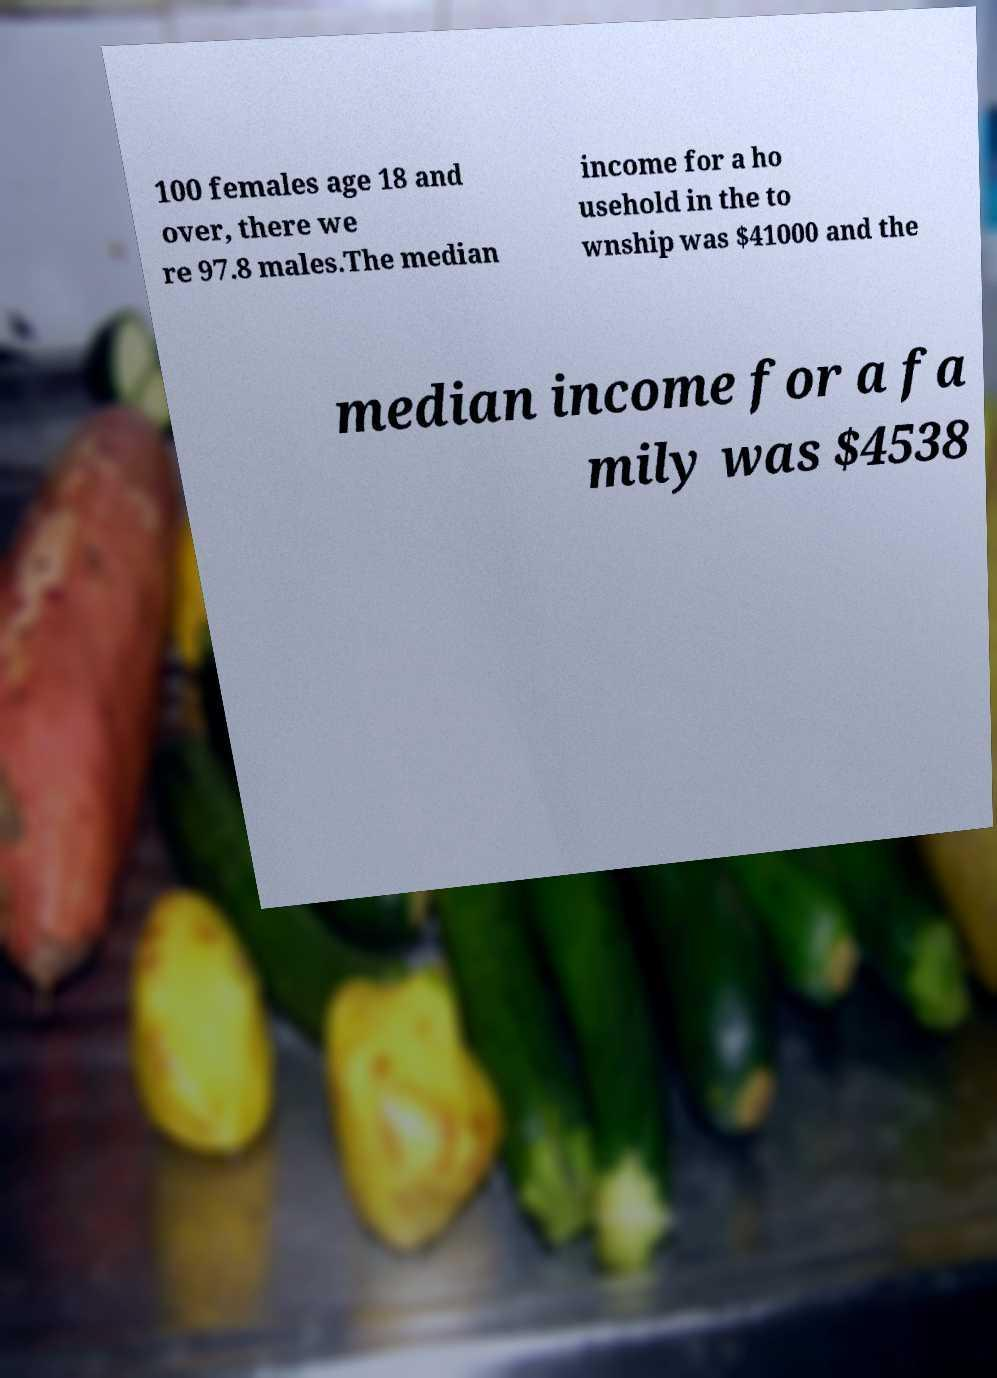Can you read and provide the text displayed in the image?This photo seems to have some interesting text. Can you extract and type it out for me? 100 females age 18 and over, there we re 97.8 males.The median income for a ho usehold in the to wnship was $41000 and the median income for a fa mily was $4538 